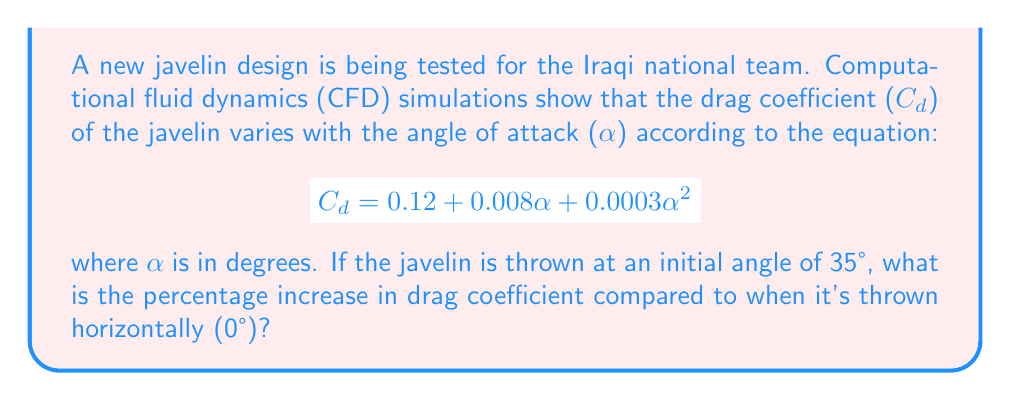Teach me how to tackle this problem. To solve this problem, we'll follow these steps:

1) Calculate $C_d$ at 0°:
   $$C_d(0°) = 0.12 + 0.008(0) + 0.0003(0)^2 = 0.12$$

2) Calculate $C_d$ at 35°:
   $$C_d(35°) = 0.12 + 0.008(35) + 0.0003(35)^2$$
   $$= 0.12 + 0.28 + 0.3675$$
   $$= 0.7675$$

3) Calculate the difference:
   $$\Delta C_d = C_d(35°) - C_d(0°) = 0.7675 - 0.12 = 0.6475$$

4) Calculate the percentage increase:
   $$\text{Percentage increase} = \frac{\Delta C_d}{C_d(0°)} \times 100\%$$
   $$= \frac{0.6475}{0.12} \times 100\% = 539.58\%$$

Therefore, the drag coefficient increases by approximately 539.58% when the javelin is thrown at a 35° angle compared to horizontally.
Answer: 539.58% 